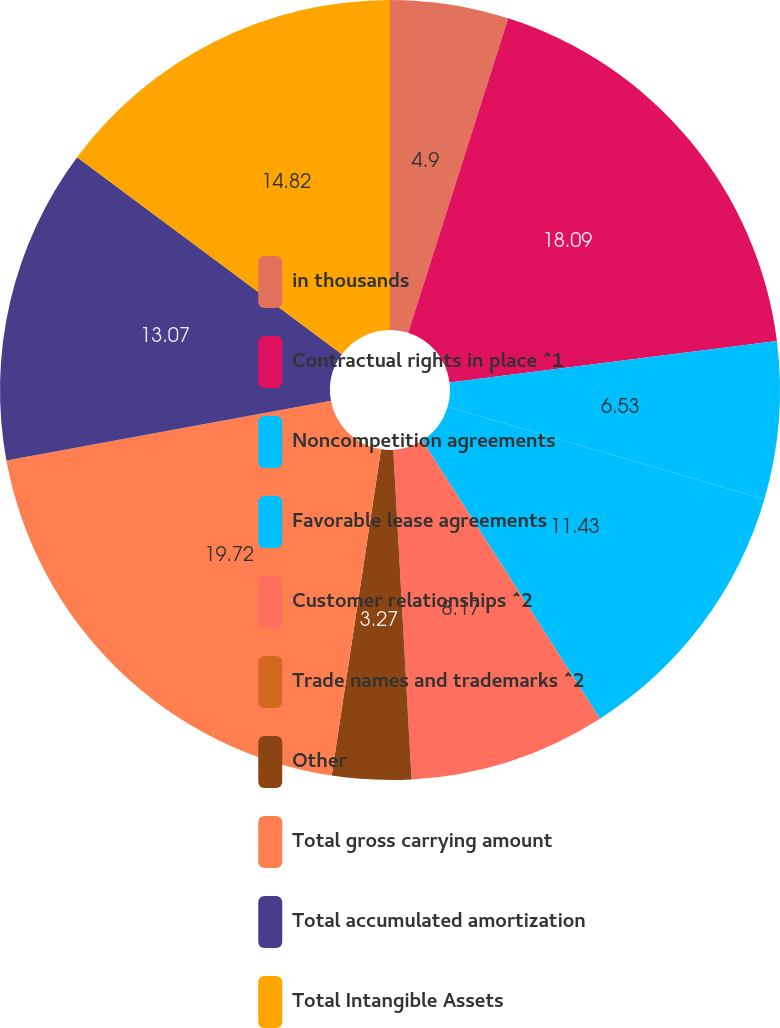Convert chart to OTSL. <chart><loc_0><loc_0><loc_500><loc_500><pie_chart><fcel>in thousands<fcel>Contractual rights in place ^1<fcel>Noncompetition agreements<fcel>Favorable lease agreements<fcel>Customer relationships ^2<fcel>Trade names and trademarks ^2<fcel>Other<fcel>Total gross carrying amount<fcel>Total accumulated amortization<fcel>Total Intangible Assets<nl><fcel>4.9%<fcel>18.09%<fcel>6.53%<fcel>11.43%<fcel>8.17%<fcel>0.0%<fcel>3.27%<fcel>19.72%<fcel>13.07%<fcel>14.82%<nl></chart> 